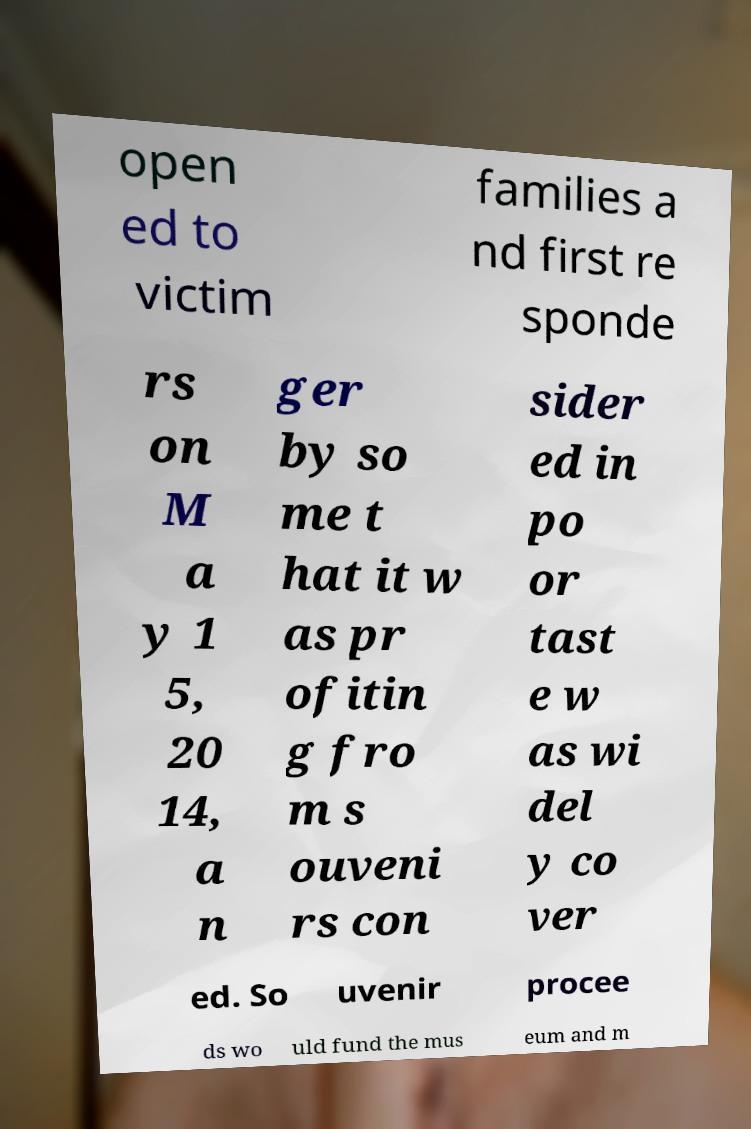Could you extract and type out the text from this image? open ed to victim families a nd first re sponde rs on M a y 1 5, 20 14, a n ger by so me t hat it w as pr ofitin g fro m s ouveni rs con sider ed in po or tast e w as wi del y co ver ed. So uvenir procee ds wo uld fund the mus eum and m 